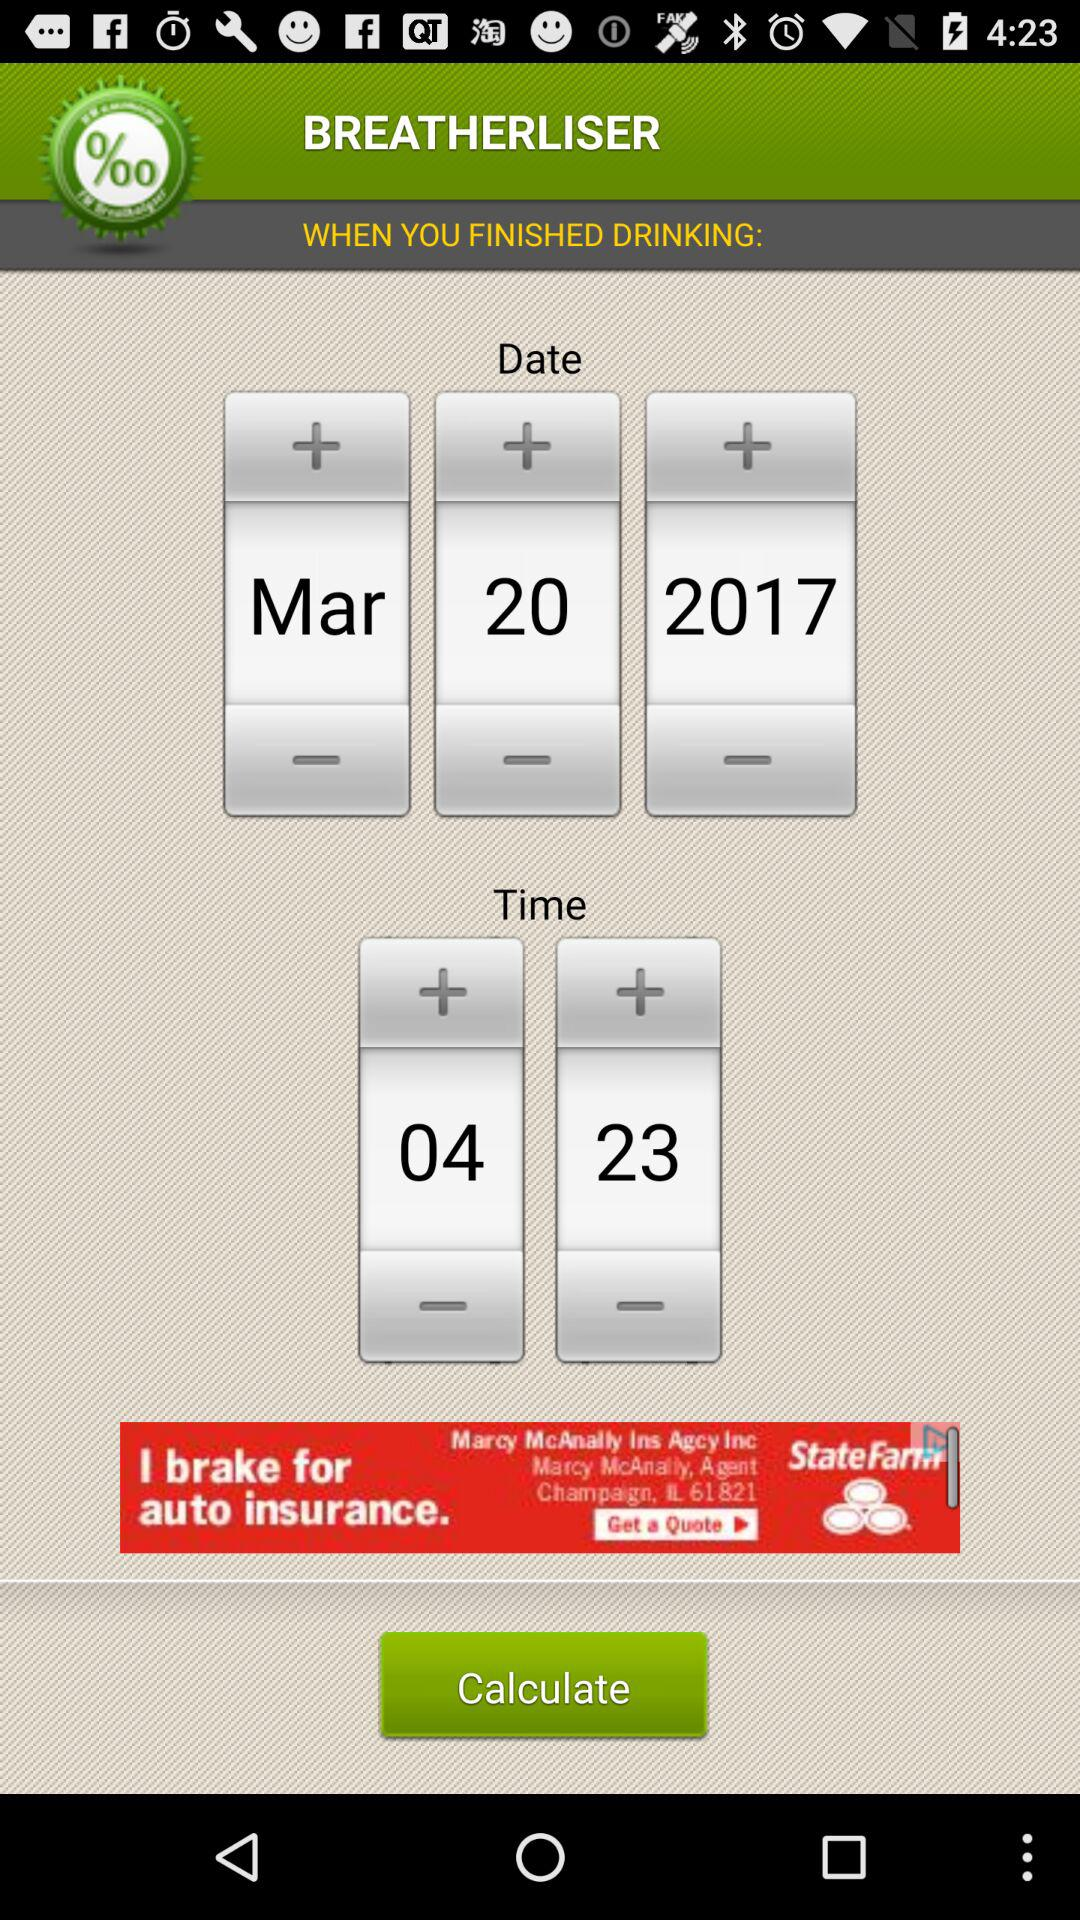What is the time in the format HH:MM?
Answer the question using a single word or phrase. 04:23 